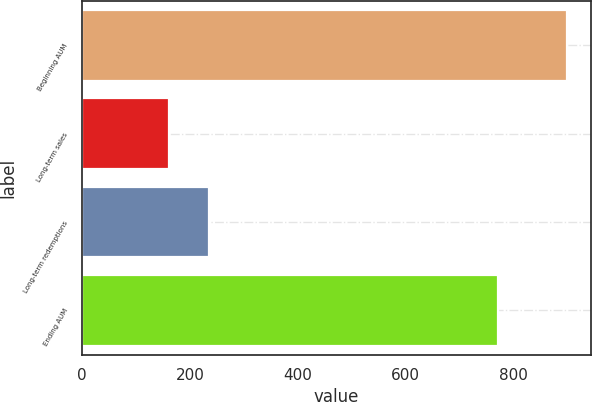Convert chart. <chart><loc_0><loc_0><loc_500><loc_500><bar_chart><fcel>Beginning AUM<fcel>Long-term sales<fcel>Long-term redemptions<fcel>Ending AUM<nl><fcel>898<fcel>161.4<fcel>235.06<fcel>770.9<nl></chart> 